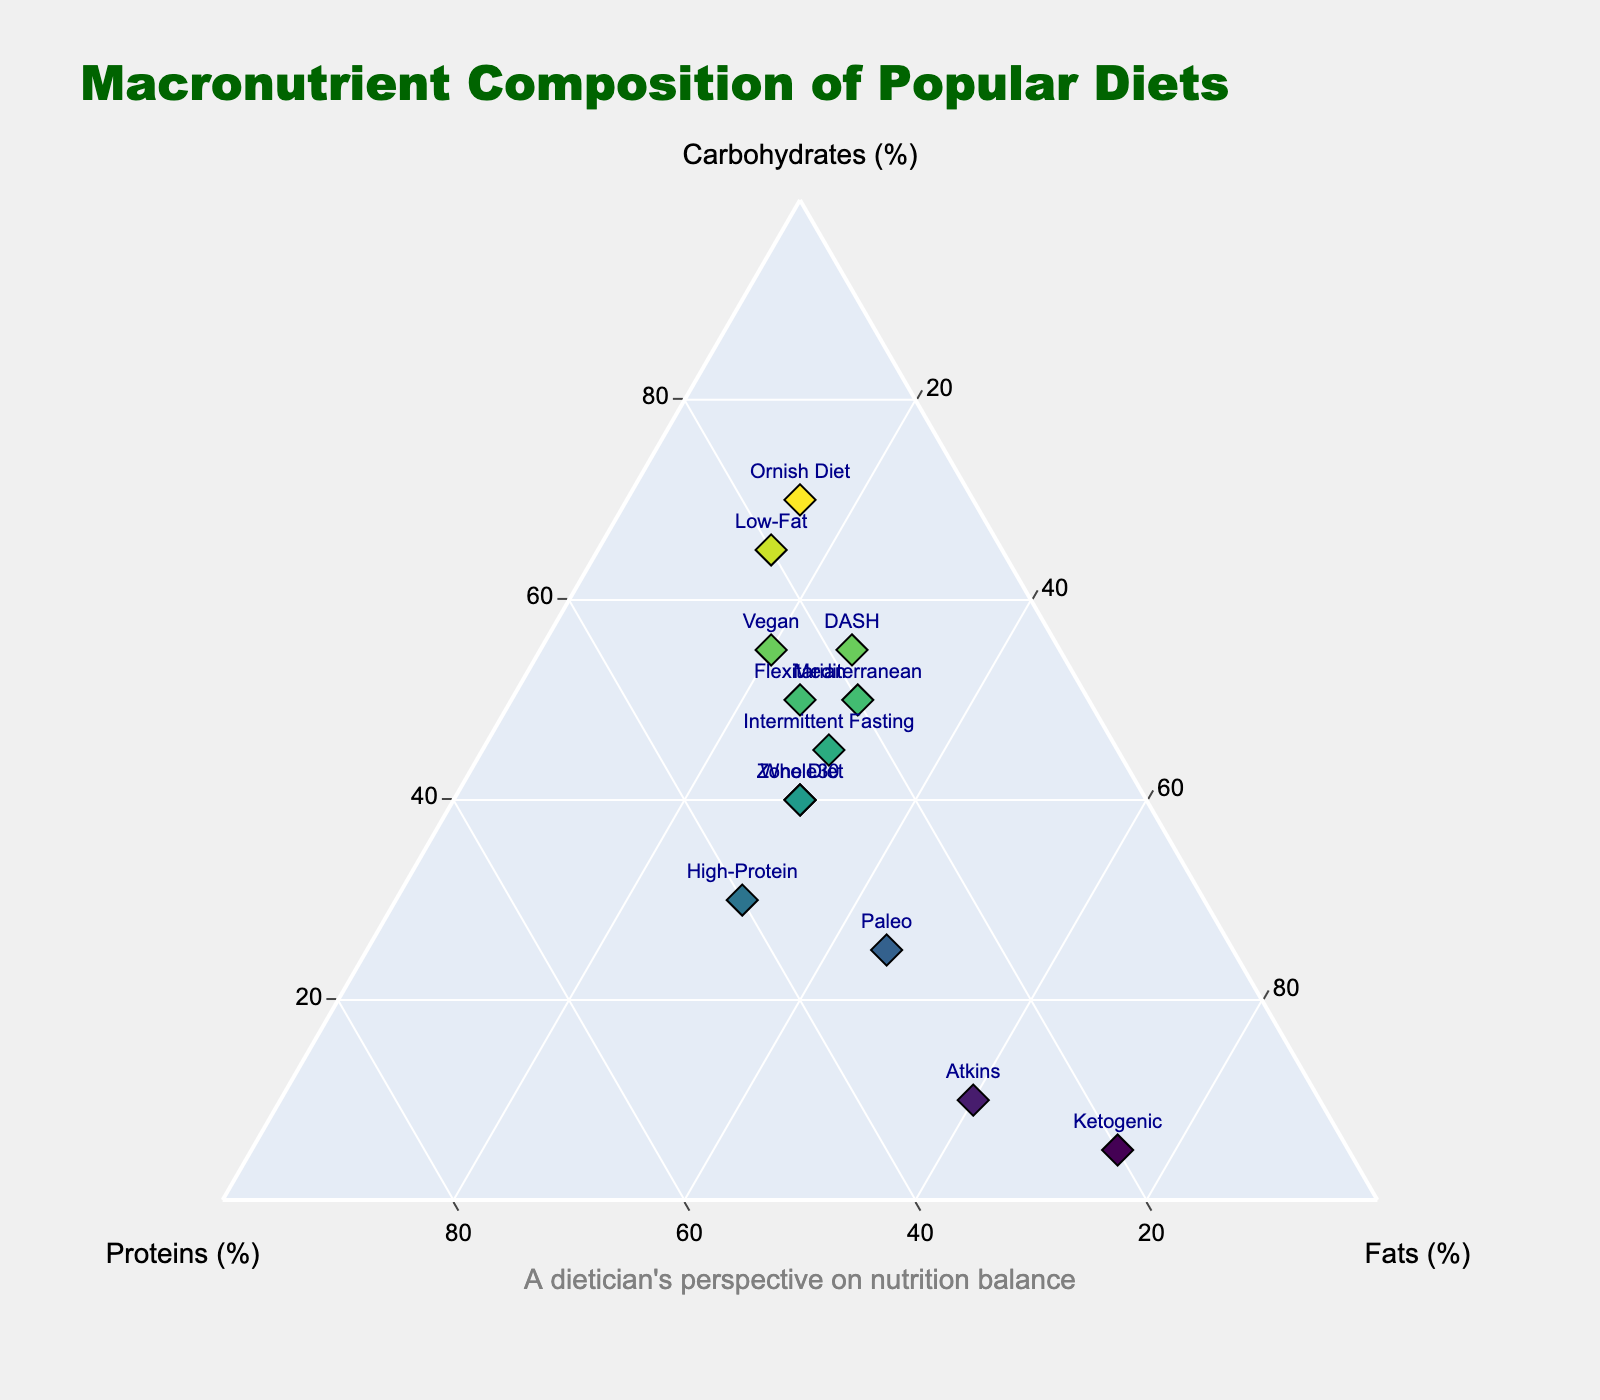What is the title of the ternary plot? The title is displayed at the top of the figure and specifies the main subject of the diagram. It reads "Macronutrient Composition of Popular Diets"
Answer: Macronutrient Composition of Popular Diets How many diets are represented in the ternary plot? By counting the distinct labels indicating each diet, we can determine the total number of data points. There are 13 unique diets.
Answer: 13 Which diet has the highest percentage of carbohydrates? By examining the placements of the points in relation to the 'Carbohydrates' axis, the diet positioned furthest towards the 'Carbohydrates' corner will be identified. The Ornish Diet, at 70%, has the highest share
Answer: Ornish Diet What is the average percentage of fats across all diets? To find the average, sum up the fat percentages for all diets and divide by the number of diets: (30 + 75 + 45 + 20 + 15 + 30 + 27 + 60 + 25 + 30 + 30 + 30 + 15) / 13 = 33%
Answer: 33% Which diet prioritizes proteins the most, and what is its percentage? Looking at the 'Proteins' axis, the diet plotted closest to the 'Proteins' corner is determined to be High-Protein, with a percentage of 40%
Answer: High-Protein, 40% Compare the carbohydrate content of the Mediterranean and Ketogenic diets. Which one has more carbohydrates, and by how much? The Mediterranean diet has 50% carbohydrates, while the Ketogenic diet has 5%. The difference is 50% - 5% = 45%.
Answer: Mediterranean diet has 45% more carbohydrates List the diets that have the same macronutrient composition. By examining the points with identical coordinates on the ternary plot, we find that the Zone Diet and Whole30 both have 40% carbohydrates, 30% proteins, and 30% fats
Answer: Zone Diet, Whole30 Which diet has the most balanced macronutrient composition? To identify the most balanced diet, look for diets with similar proportions of carbohydrates, proteins, and fats. The Zone Diet (40%, 30%, 30%) and Whole30 (40%, 30%, 30%) stand out as balanced
Answer: Zone Diet or Whole30 Does the Paleo diet have a higher percentage of proteins or fats? By inspecting the ternary plot, we see that the Paleo diet is positioned closer to the 'Fats' axis compared to 'Proteins'. It has 45% fats compared to 30% proteins
Answer: Fats Which diet is closest to the 'Proteins (%)' axis, indicating a lower protein content? Observing the ternary plot, the diet positioned closest to the 'Proteins (%)' axis, indicating it has the least proteins, is the Ornish Diet with only 15% proteins
Answer: Ornish Diet 